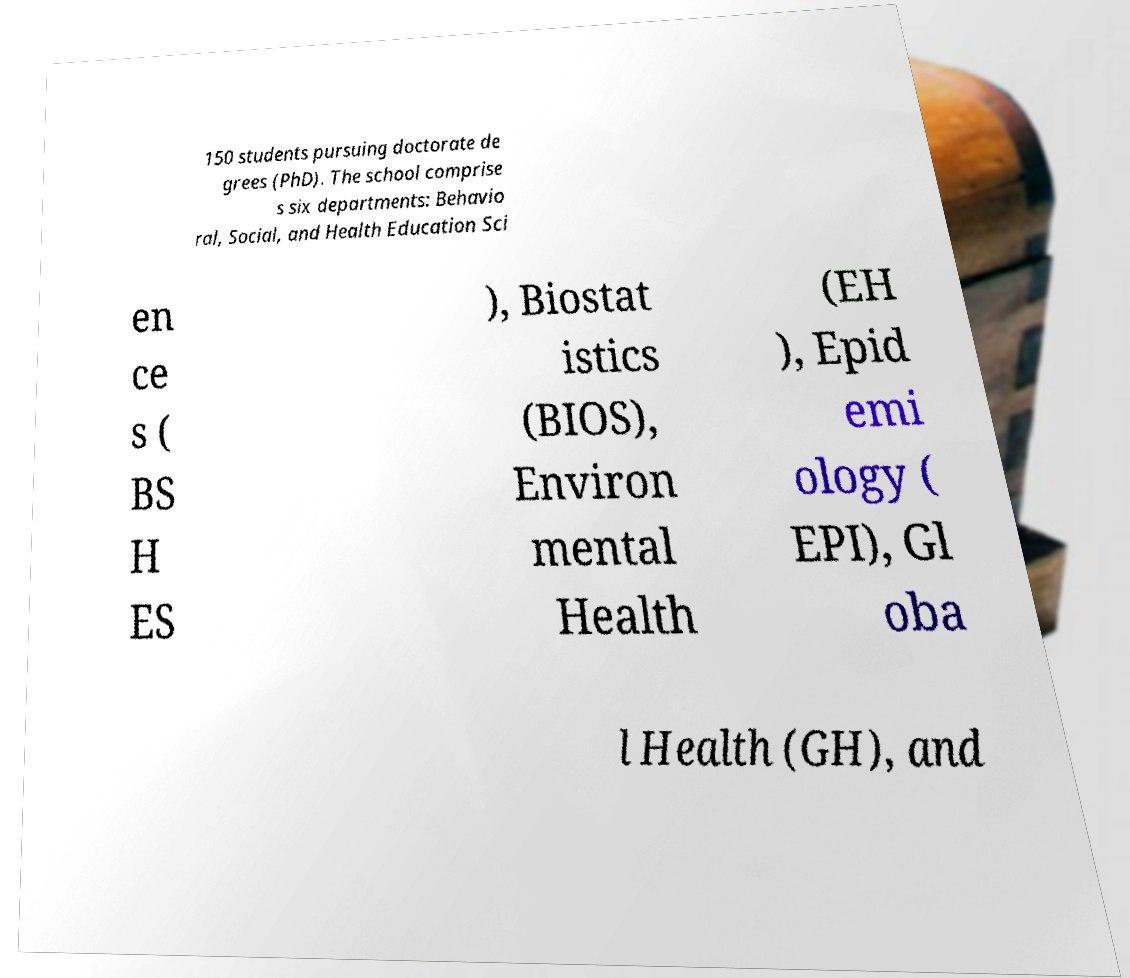Could you assist in decoding the text presented in this image and type it out clearly? 150 students pursuing doctorate de grees (PhD). The school comprise s six departments: Behavio ral, Social, and Health Education Sci en ce s ( BS H ES ), Biostat istics (BIOS), Environ mental Health (EH ), Epid emi ology ( EPI), Gl oba l Health (GH), and 